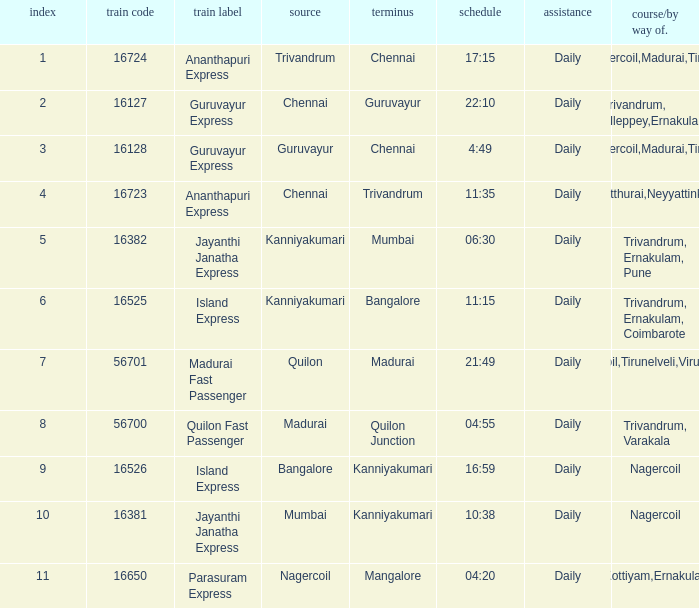What is the train number when the time is 10:38? 16381.0. 